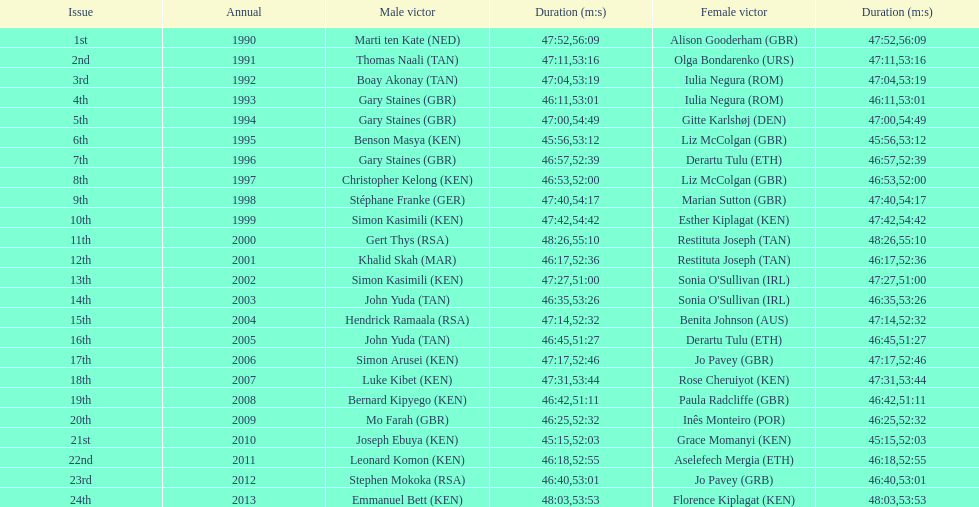Who is the male triumphant individual listed preceding gert thys? Simon Kasimili. 